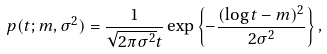Convert formula to latex. <formula><loc_0><loc_0><loc_500><loc_500>p ( t ; m , \sigma ^ { 2 } ) = \frac { 1 } { \sqrt { 2 \pi \sigma ^ { 2 } } t } \exp \left \{ - \frac { ( \log t - m ) ^ { 2 } } { 2 \sigma ^ { 2 } } \right \} ,</formula> 